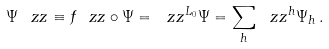Convert formula to latex. <formula><loc_0><loc_0><loc_500><loc_500>\Psi ^ { \ } z z \equiv f _ { \ } z z \circ \Psi = \ z z ^ { L _ { 0 } } \Psi = \sum _ { h } \ z z ^ { h } \Psi _ { h } \, .</formula> 